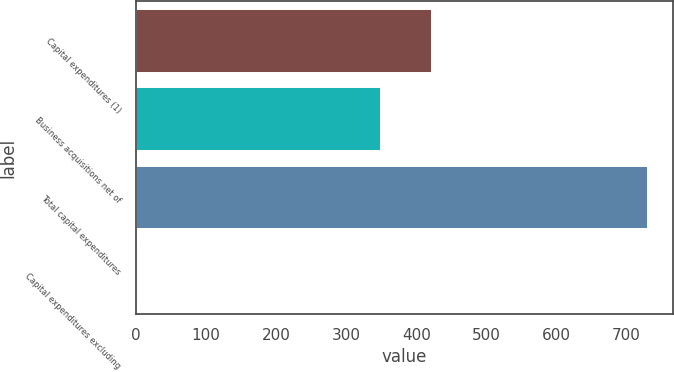Convert chart. <chart><loc_0><loc_0><loc_500><loc_500><bar_chart><fcel>Capital expenditures (1)<fcel>Business acquisitions net of<fcel>Total capital expenditures<fcel>Capital expenditures excluding<nl><fcel>421.63<fcel>349<fcel>729<fcel>2.7<nl></chart> 